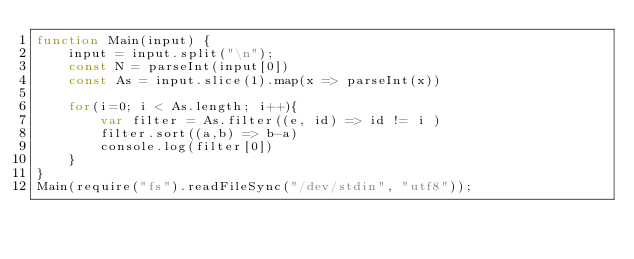Convert code to text. <code><loc_0><loc_0><loc_500><loc_500><_JavaScript_>function Main(input) {
	input = input.split("\n");
	const N = parseInt(input[0])
	const As = input.slice(1).map(x => parseInt(x))

	for(i=0; i < As.length; i++){
		var filter = As.filter((e, id) => id != i )
		filter.sort((a,b) => b-a)
		console.log(filter[0])
	}
}
Main(require("fs").readFileSync("/dev/stdin", "utf8"));</code> 